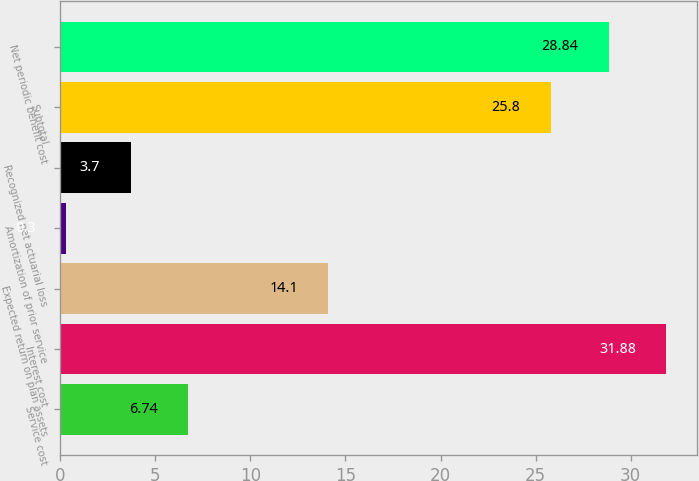Convert chart. <chart><loc_0><loc_0><loc_500><loc_500><bar_chart><fcel>Service cost<fcel>Interest cost<fcel>Expected return on plan assets<fcel>Amortization of prior service<fcel>Recognized net actuarial loss<fcel>Subtotal<fcel>Net periodic benefit cost<nl><fcel>6.74<fcel>31.88<fcel>14.1<fcel>0.3<fcel>3.7<fcel>25.8<fcel>28.84<nl></chart> 